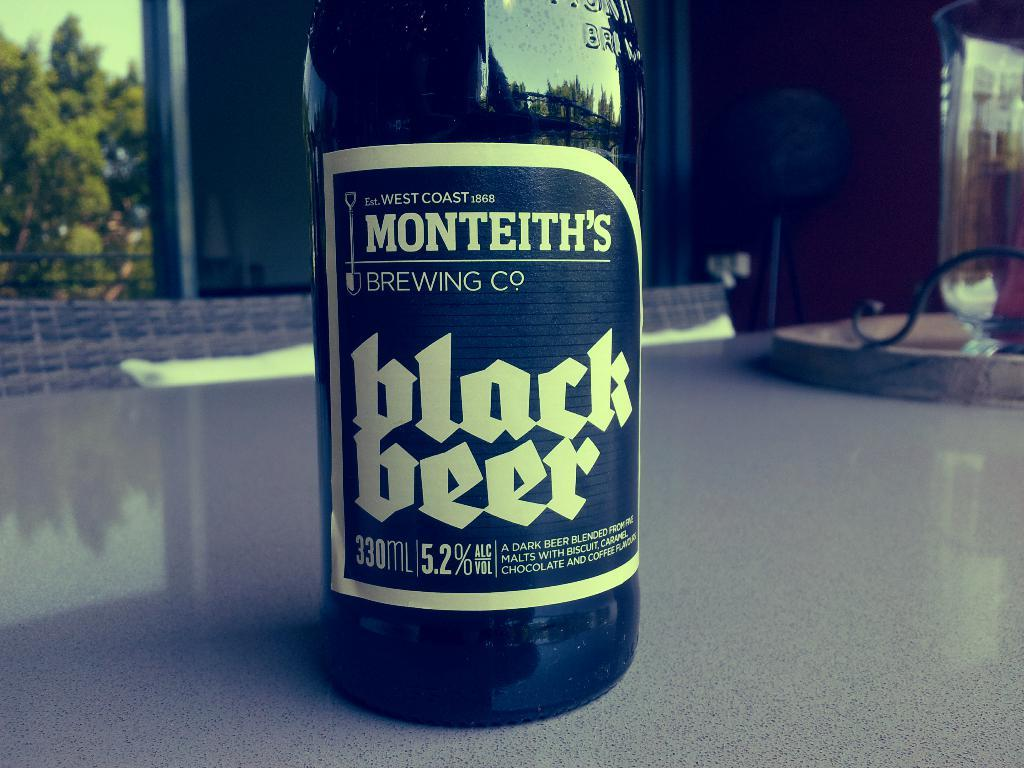<image>
Describe the image concisely. A bottle of Monteith's Black Beer sits on a counter top. 